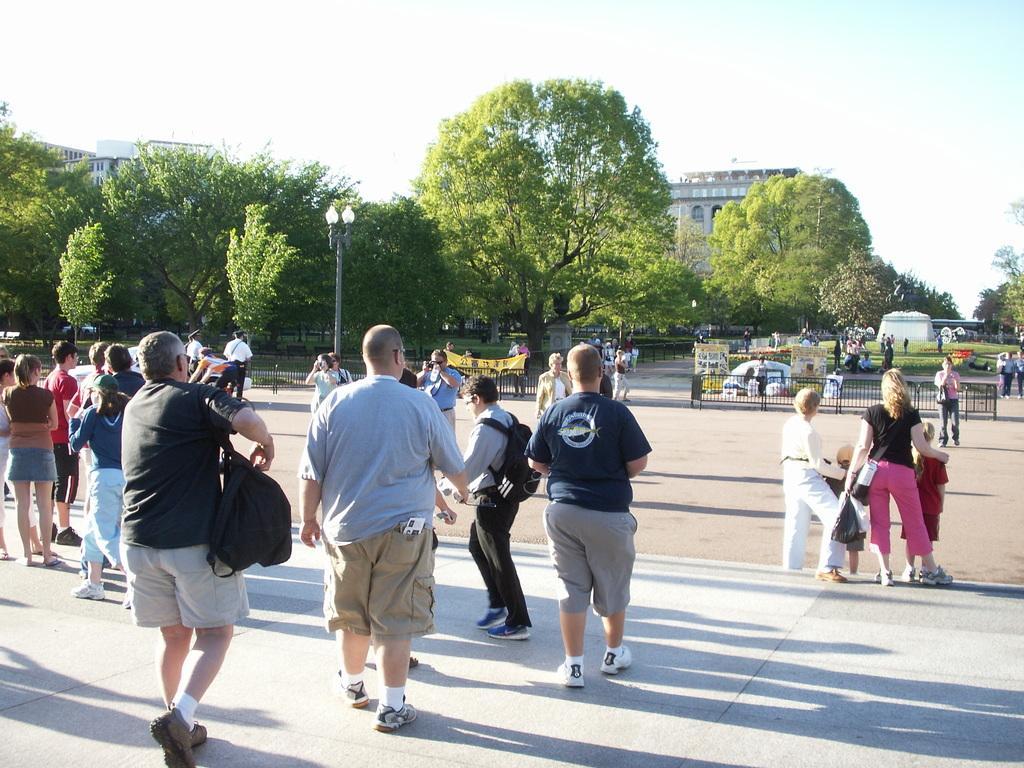Describe this image in one or two sentences. Here some people are standing and some people are walking, here there are trees and buildings, this is sky. 